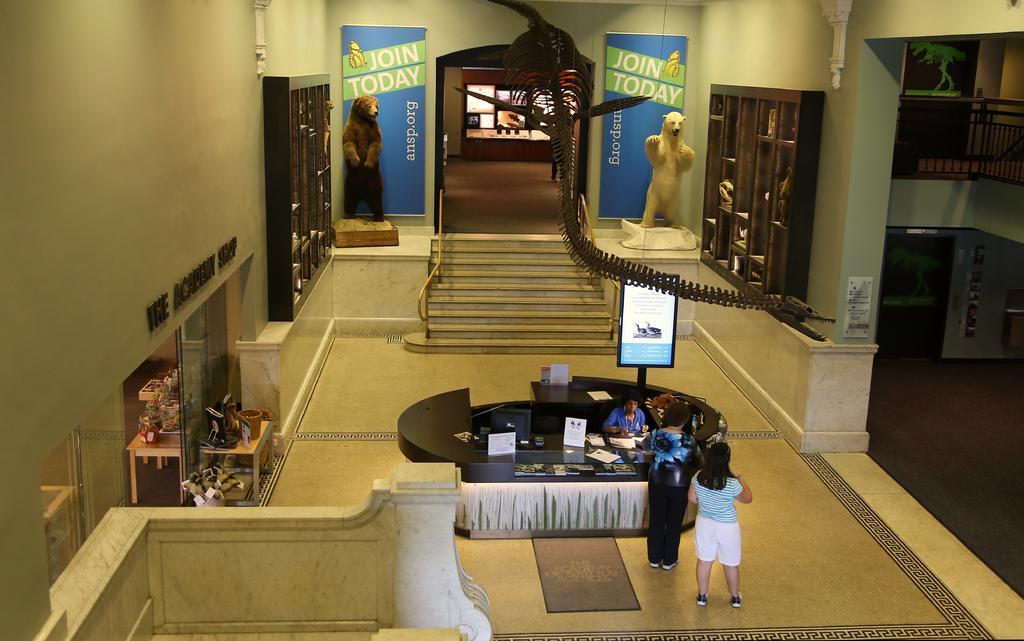Please provide a concise description of this image. In this image we can see some people beside a table containing some papers and devices on it. We can also see a table with some objects on it, the skeleton of an animal, a staircase, statues, some objects placed in the cupboards and the banners with some text on them. On the right side we can see a paper and some pictures on a wall and the railing. 